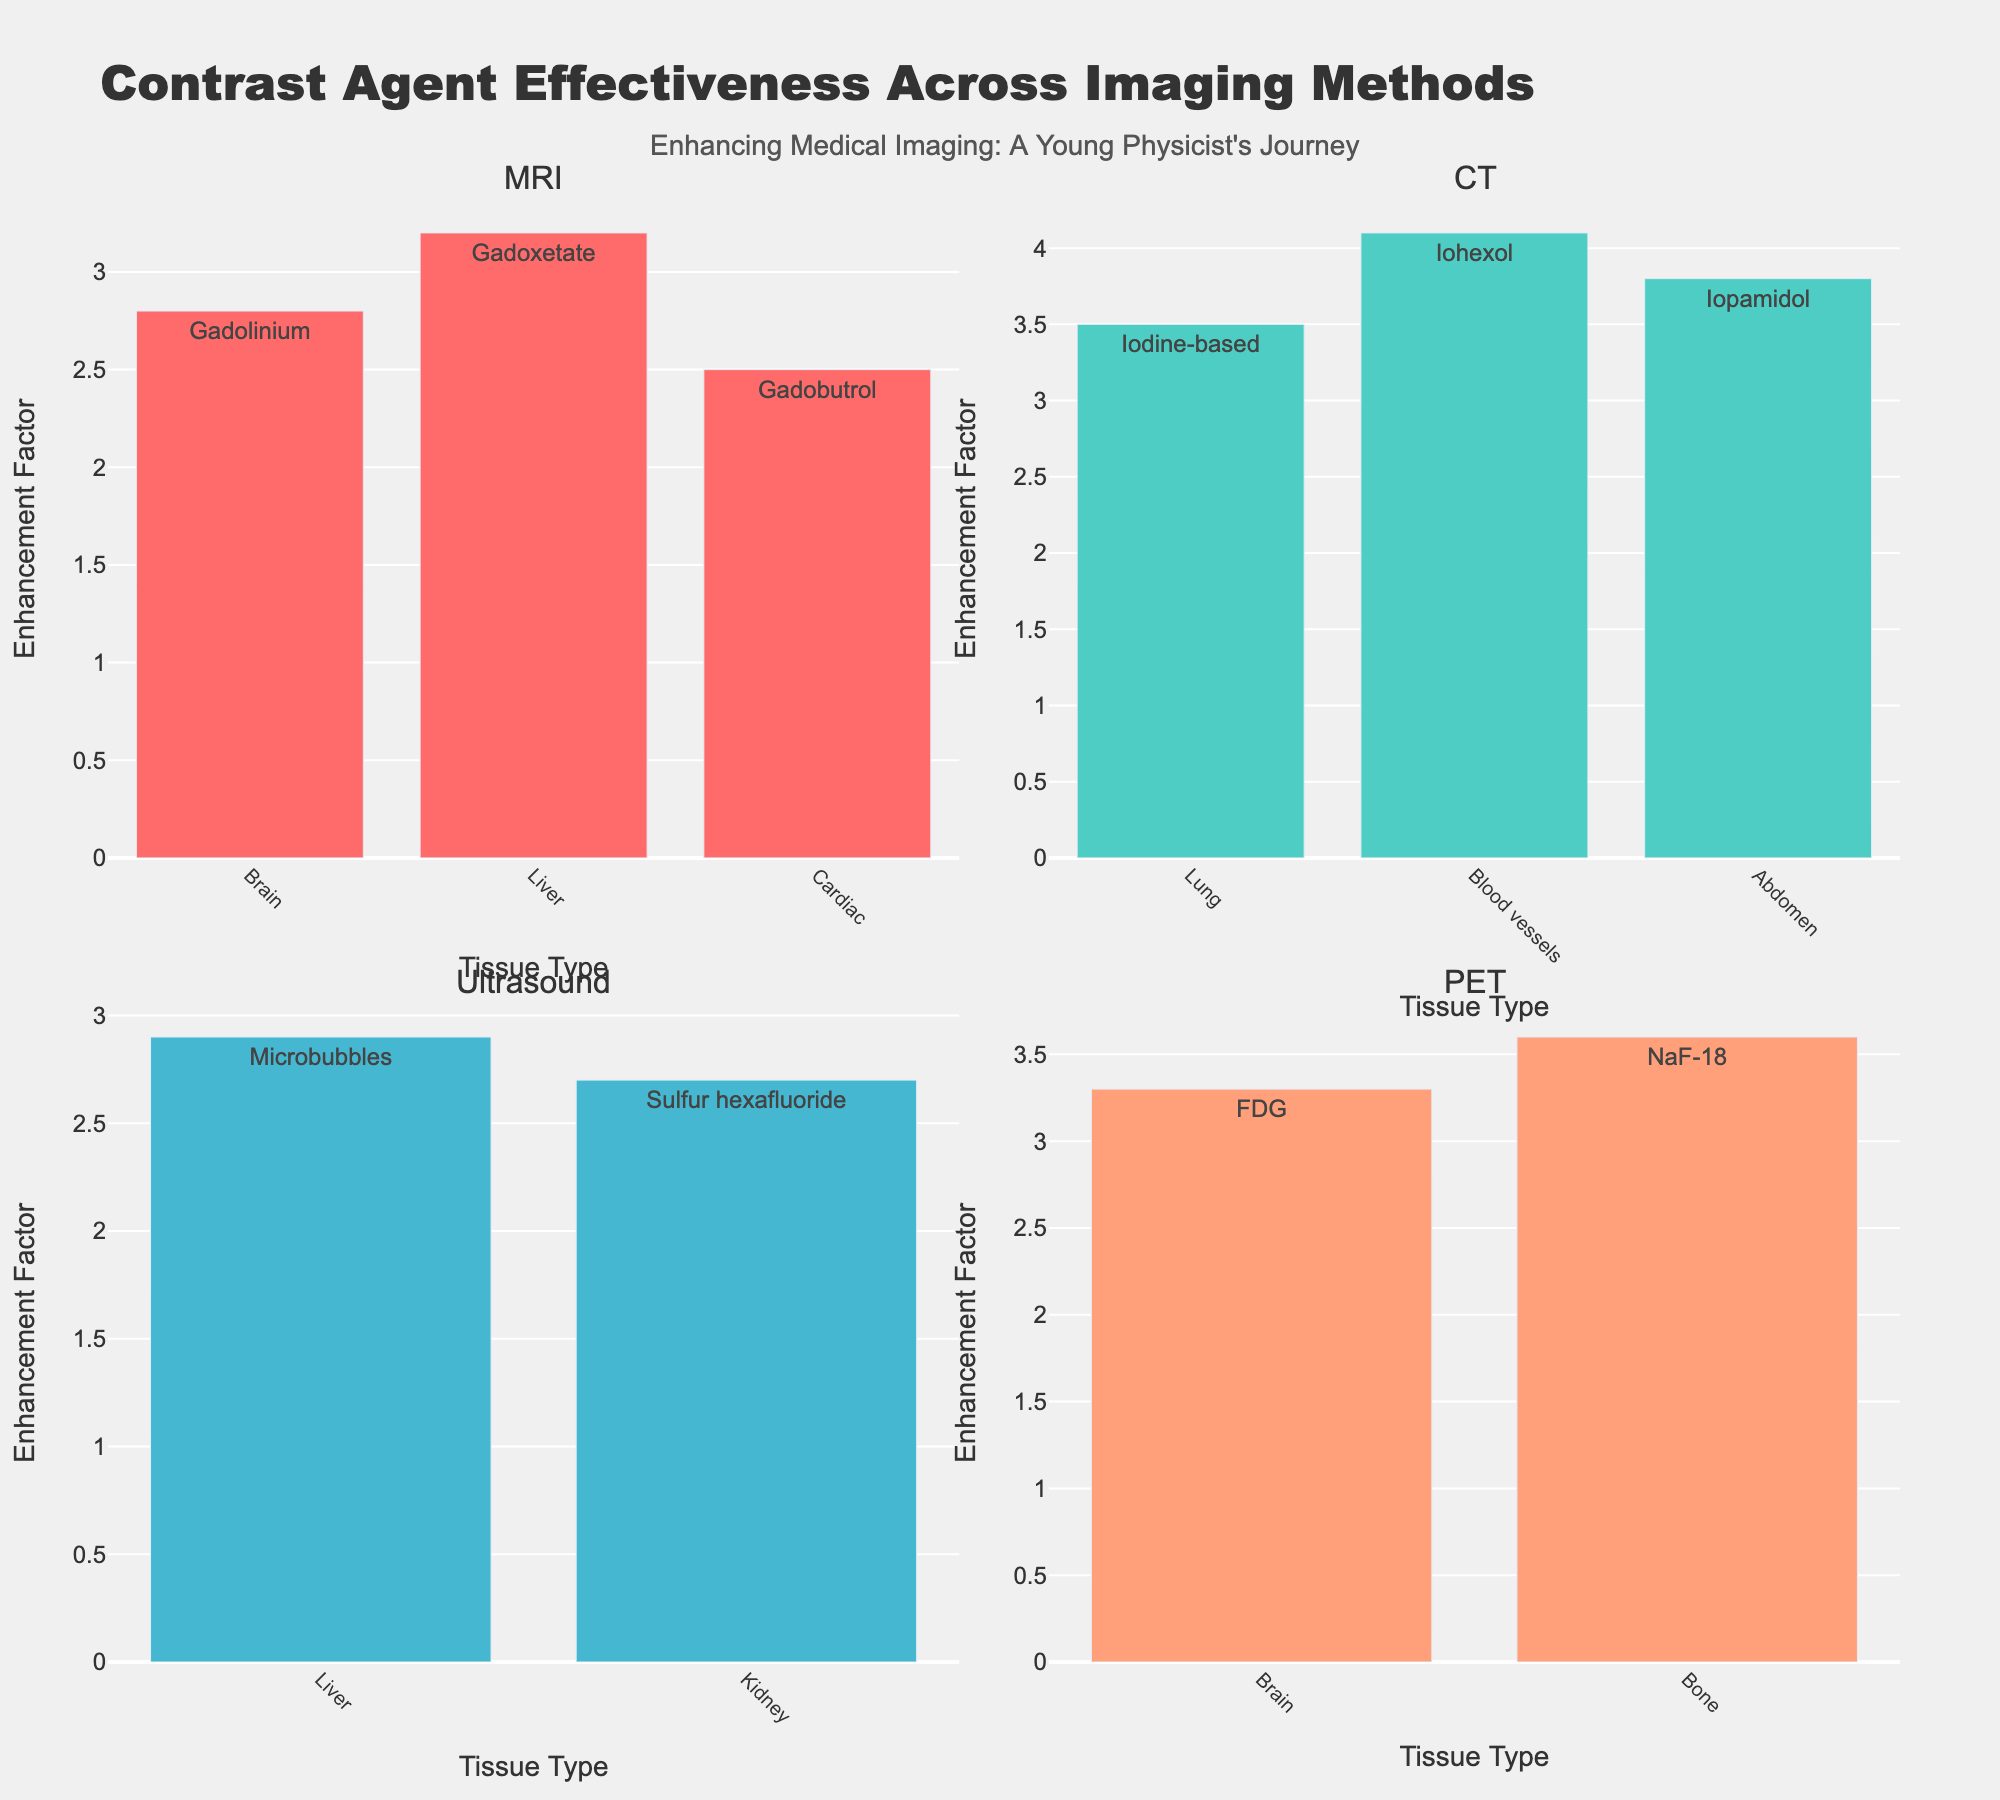What is the title of the figure? The title is displayed at the top of the figure, highlighting the overall theme of the plot.
Answer: Contrast Agent Effectiveness Across Imaging Methods Which imaging method has the highest enhancement factor, and for which tissue type is it? Look at all the subplots and identify the maximum enhancement factor. It is found under CT imaging for Blood vessels with an enhancement factor of 4.1.
Answer: CT, Blood vessels What tissue type does Gadolinium target and what is its enhancement factor? In the MRI subplot, locate the bar representing Gadolinium and note its corresponding tissue type and enhancement factor. Gadolinium targets Brain and has an enhancement factor of 2.8.
Answer: Brain, 2.8 How does the enhancement factor of Iodine-based contrast agents in CT for the Lung compare to that of Iopamidol in CT for the Abdomen? Compare the heights of the bars within the CT subplot for the Lung and Abdomen. Iodine-based agents enhance Lung with a factor of 3.5, while Iopamidol enhances Abdomen with a factor of 3.8. Iopamidol is higher.
Answer: Iopamidol is higher What is the overall median enhancement factor for all contrast agents across all imaging methods? List and sort all the enhancement factors, then calculate the median. The factors are [2.5, 2.7, 2.8, 2.9, 3.2, 3.3, 3.5, 3.6, 3.8, 4.1]. The median is the average of the 5th and 6th values, (3.2 + 3.3) / 2 = 3.25.
Answer: 3.25 Which contrast agent provides the highest enhancement in PET imaging and for which tissue type? Check the PET subplot for the highest bar and identify the contrast agent and corresponding tissue type. NaF-18 provides the highest enhancement for Bone.
Answer: NaF-18, Bone Comparing MRI and Ultrasound, which imaging method has a higher average enhancement factor? Calculate the average enhancement factor for each method: MRI (2.8+3.2+2.5)/3 ≈ 2.83, Ultrasound (2.9+2.7)/2 = 2.8. MRI has a slightly higher average.
Answer: MRI How many contrast agents are used in enhancing Brain tissue across all imaging methods, and what are they? Find and count all the bars labeled with Brain across the subplots, noting the corresponding contrast agents: MRI uses Gadolinium, and PET uses FDG. There are 2 contrast agents.
Answer: 2, Gadolinium and FDG What is the range of enhancement factors for contrast agents in CT imaging? Identify the minimum and maximum enhancement factors in the CT subplot. The range is from the lowest value (3.5) to the highest value (4.1), yielding a range of 0.6.
Answer: 0.6 Which contrast agent is used for Liver tissue in Ultrasound imaging, and what is its enhancement factor? In the Ultrasound subplot, look for the bar corresponding to Liver tissue. The contrast agent is Microbubbles, with an enhancement factor of 2.9.
Answer: Microbubbles, 2.9 